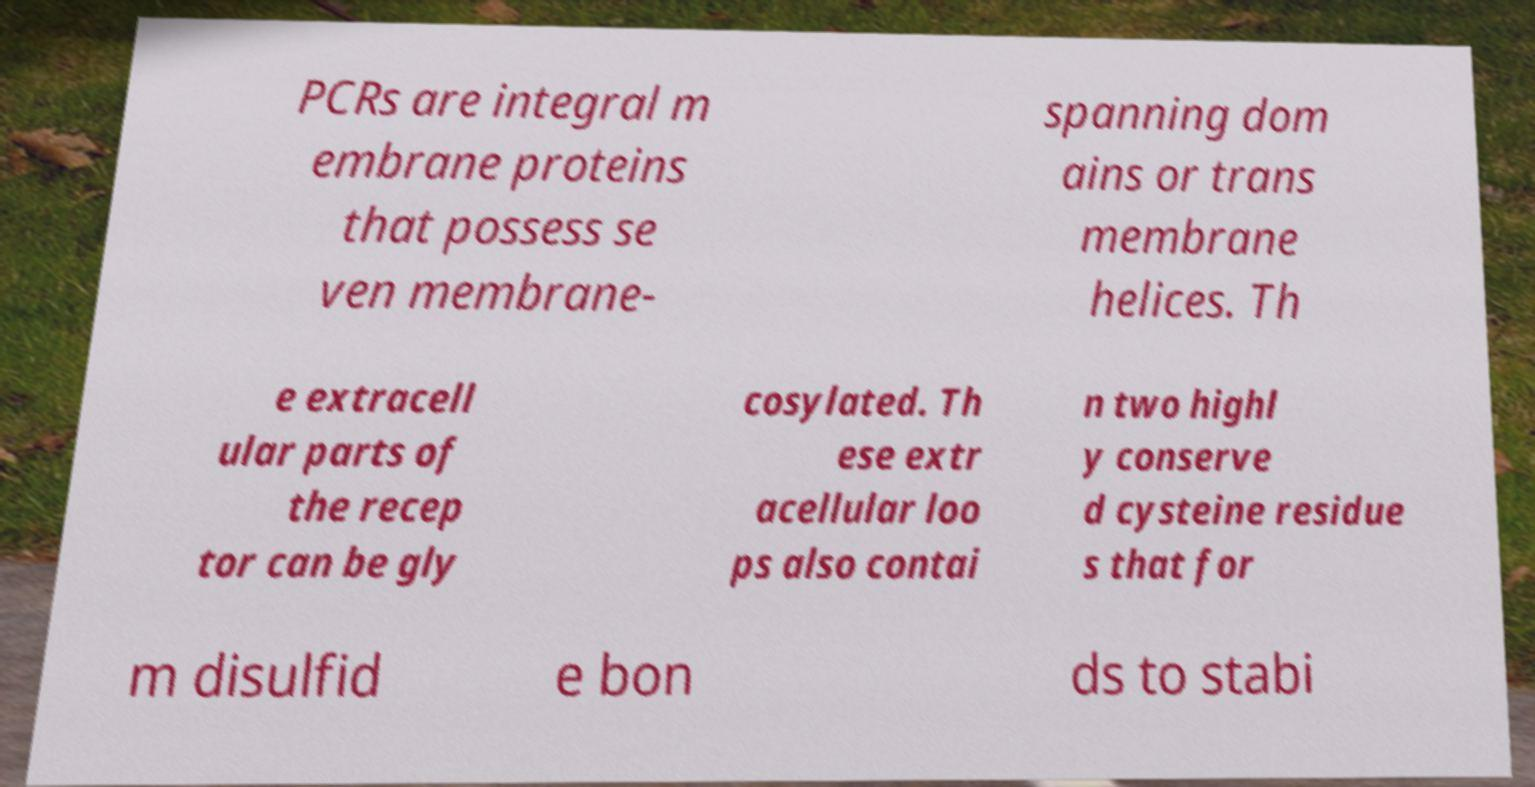I need the written content from this picture converted into text. Can you do that? PCRs are integral m embrane proteins that possess se ven membrane- spanning dom ains or trans membrane helices. Th e extracell ular parts of the recep tor can be gly cosylated. Th ese extr acellular loo ps also contai n two highl y conserve d cysteine residue s that for m disulfid e bon ds to stabi 